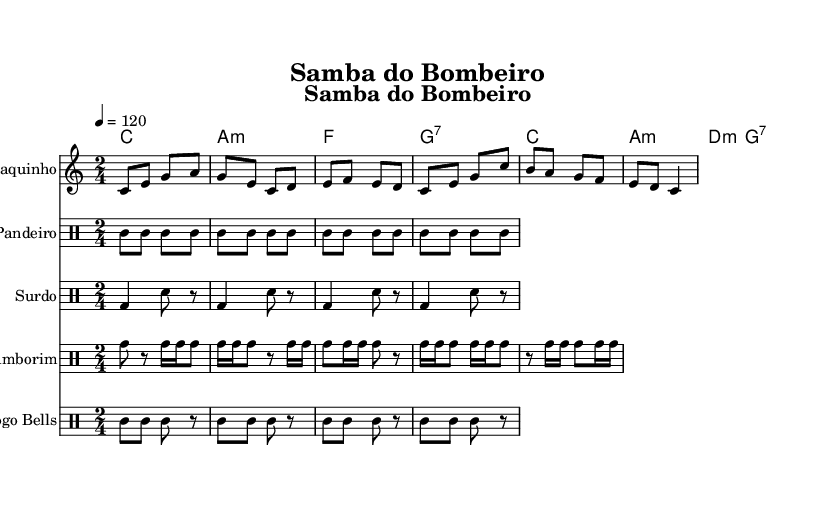What is the key signature of this music? The key signature is specified as C major, which has no sharps or flats. You can identify the key signature by looking at the global settings at the beginning of the code where ' \key c \major' is indicated.
Answer: C major What is the time signature of this music? The time signature is indicated in the global settings section, which states '\time 2/4'. This means each measure contains two beats, and the quarter note gets one beat.
Answer: 2/4 What is the tempo marking of this piece? The tempo marking is given in the global settings, listed as ' \tempo 4 = 120'. This indicates that the tempo is set at 120 beats per minute.
Answer: 120 How many different percussion instruments are included in the arrangement? The arrangement includes four different percussion instruments, as seen in the sections beginning with ' \new DrumStaff' for Pandeiro, Surdo, Tamborim, and Agogo Bells.
Answer: Four What lyrics accompany the verse of this piece? The lyrics of the verse are found in the section '\new Lyrics \lyricsto "cavaquinho"', which states the lines that convey the theme of gathering and dancing away cares after a shift.
Answer: After the flames, we gather here, to wash away the smoke and fear, with samba rhythms in our ears, we'll dance away our cares Which musical form is predominantly used in this samba piece? The musical form here predominantly follows a verse-chorus structure. The verses describe a narrative, followed by a chorus that summarizes the themes of camaraderie and unwinding, typical of samba music.
Answer: Verse-Chorus What is the rhythm pattern primarily used in the percussion? The rhythm pattern in the percussion parts varies, but they all primarily maintain a consistent samba rhythm characterized by syncopation and a lively groove. You can observe this in the notated parts for Pandeiro, Surdo, Tamborim, and Agogo Bells.
Answer: Samba rhythm 